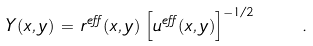Convert formula to latex. <formula><loc_0><loc_0><loc_500><loc_500>Y ( x , y ) \, = \, r ^ { e f f } ( x , y ) \, \left [ u ^ { e f f } ( x , y ) \right ] ^ { - 1 / 2 } \quad .</formula> 